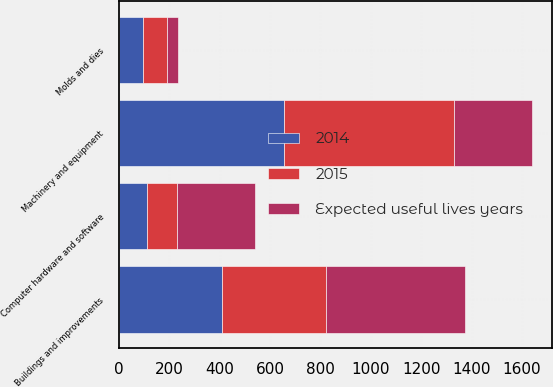Convert chart. <chart><loc_0><loc_0><loc_500><loc_500><stacked_bar_chart><ecel><fcel>Buildings and improvements<fcel>Machinery and equipment<fcel>Molds and dies<fcel>Computer hardware and software<nl><fcel>Expected useful lives years<fcel>550<fcel>310<fcel>47<fcel>310<nl><fcel>2015<fcel>412.8<fcel>674.8<fcel>94.4<fcel>118.3<nl><fcel>2014<fcel>410.6<fcel>654.1<fcel>94.8<fcel>111.3<nl></chart> 